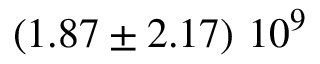Convert formula to latex. <formula><loc_0><loc_0><loc_500><loc_500>\left ( 1 . 8 7 \pm 2 . 1 7 \right ) \, 1 0 ^ { 9 }</formula> 